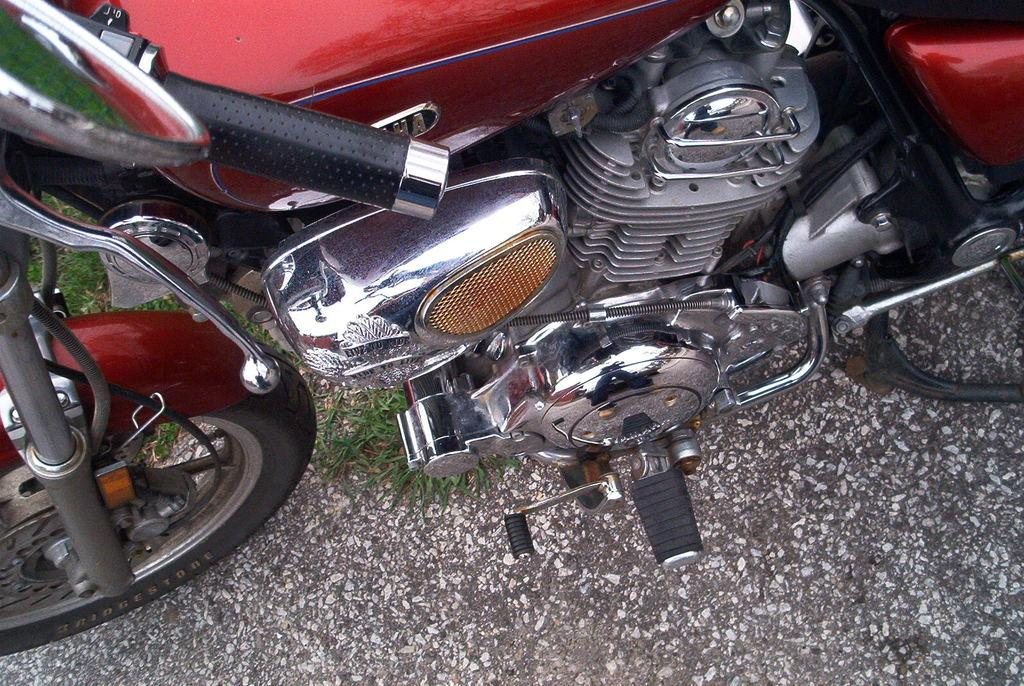What type of vehicle is in the image? There is a red color bike in the image. Where is the bike located? The bike is parked on the road. What type of vegetation can be seen in the image? There is grass visible in the image. How many girls are wearing sweaters while standing next to the vase in the image? There are no girls, sweaters, or vases present in the image. 